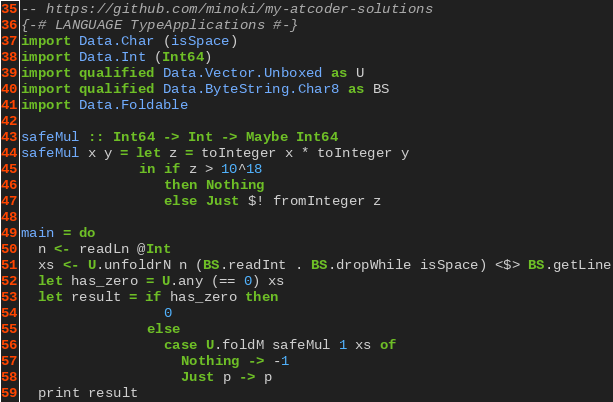Convert code to text. <code><loc_0><loc_0><loc_500><loc_500><_Haskell_>-- https://github.com/minoki/my-atcoder-solutions
{-# LANGUAGE TypeApplications #-}
import Data.Char (isSpace)
import Data.Int (Int64)
import qualified Data.Vector.Unboxed as U
import qualified Data.ByteString.Char8 as BS
import Data.Foldable

safeMul :: Int64 -> Int -> Maybe Int64
safeMul x y = let z = toInteger x * toInteger y
              in if z > 10^18
                 then Nothing
                 else Just $! fromInteger z

main = do
  n <- readLn @Int
  xs <- U.unfoldrN n (BS.readInt . BS.dropWhile isSpace) <$> BS.getLine
  let has_zero = U.any (== 0) xs
  let result = if has_zero then
                 0
               else
                 case U.foldM safeMul 1 xs of
                   Nothing -> -1
                   Just p -> p
  print result
</code> 